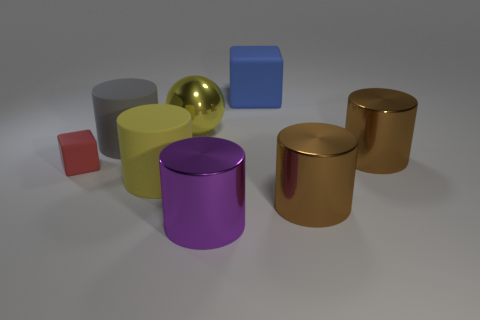Does the large matte block have the same color as the large shiny sphere?
Offer a very short reply. No. What is the shape of the large gray matte object that is in front of the block that is on the right side of the big metal sphere?
Your response must be concise. Cylinder. Are the thing that is behind the big yellow metallic thing and the cube left of the big yellow cylinder made of the same material?
Make the answer very short. Yes. There is a ball that is the same size as the yellow cylinder; what color is it?
Provide a short and direct response. Yellow. Is there anything else that is the same color as the sphere?
Keep it short and to the point. Yes. There is a brown cylinder that is on the left side of the brown shiny cylinder behind the rubber cube that is in front of the large yellow metal thing; what is its size?
Your response must be concise. Large. There is a large metal object that is both left of the blue rubber cube and behind the big purple thing; what is its color?
Your response must be concise. Yellow. What size is the matte block in front of the blue object?
Provide a succinct answer. Small. What number of big brown things have the same material as the big blue cube?
Keep it short and to the point. 0. What shape is the thing that is the same color as the large metallic ball?
Give a very brief answer. Cylinder. 